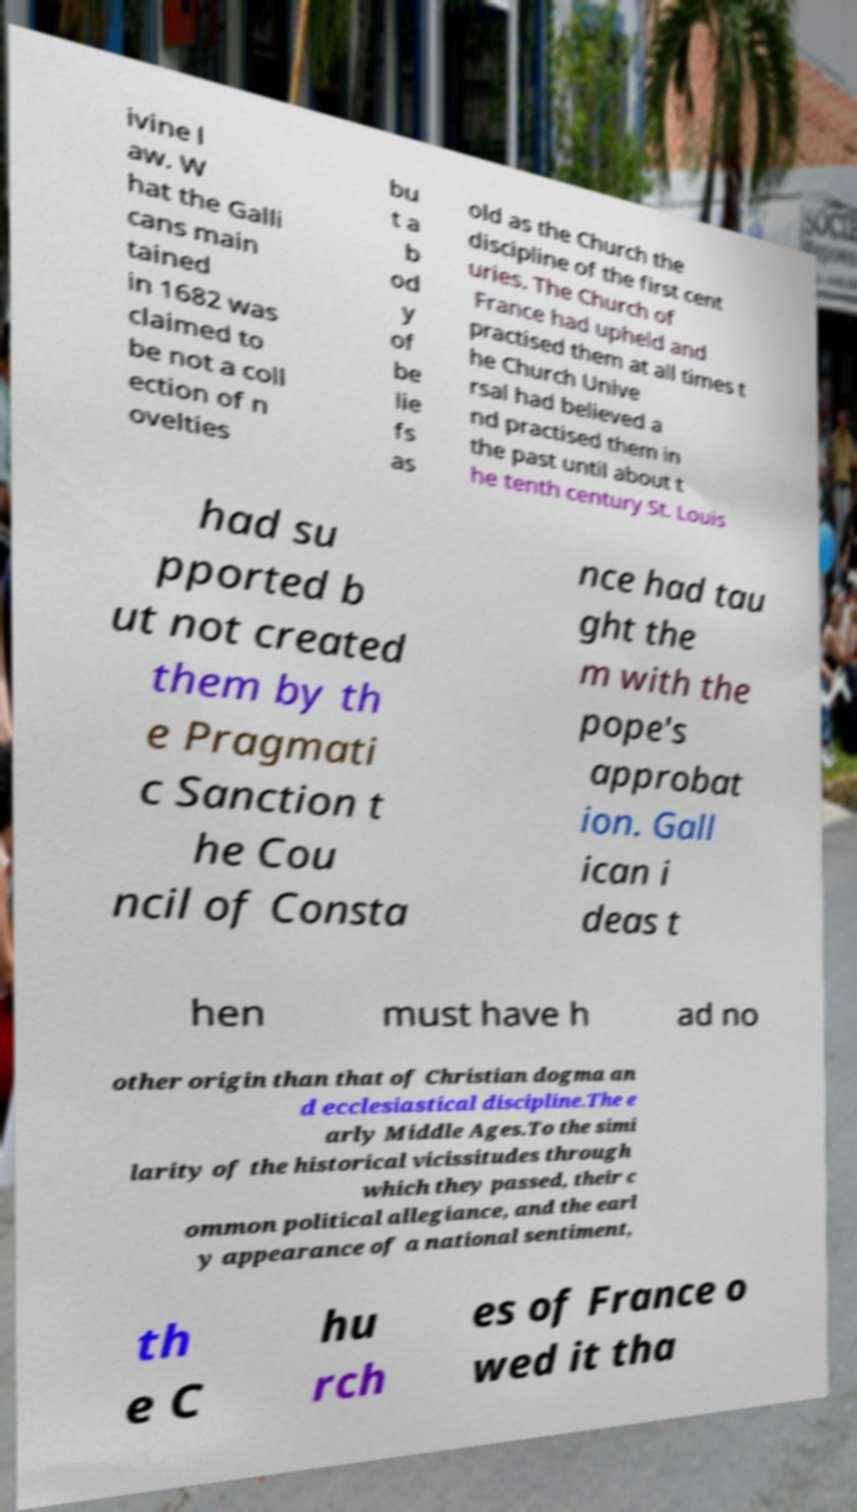What messages or text are displayed in this image? I need them in a readable, typed format. ivine l aw. W hat the Galli cans main tained in 1682 was claimed to be not a coll ection of n ovelties bu t a b od y of be lie fs as old as the Church the discipline of the first cent uries. The Church of France had upheld and practised them at all times t he Church Unive rsal had believed a nd practised them in the past until about t he tenth century St. Louis had su pported b ut not created them by th e Pragmati c Sanction t he Cou ncil of Consta nce had tau ght the m with the pope's approbat ion. Gall ican i deas t hen must have h ad no other origin than that of Christian dogma an d ecclesiastical discipline.The e arly Middle Ages.To the simi larity of the historical vicissitudes through which they passed, their c ommon political allegiance, and the earl y appearance of a national sentiment, th e C hu rch es of France o wed it tha 